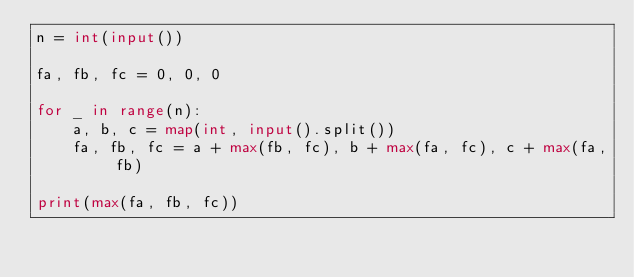Convert code to text. <code><loc_0><loc_0><loc_500><loc_500><_Python_>n = int(input())

fa, fb, fc = 0, 0, 0

for _ in range(n):
    a, b, c = map(int, input().split())
    fa, fb, fc = a + max(fb, fc), b + max(fa, fc), c + max(fa, fb)

print(max(fa, fb, fc))
</code> 